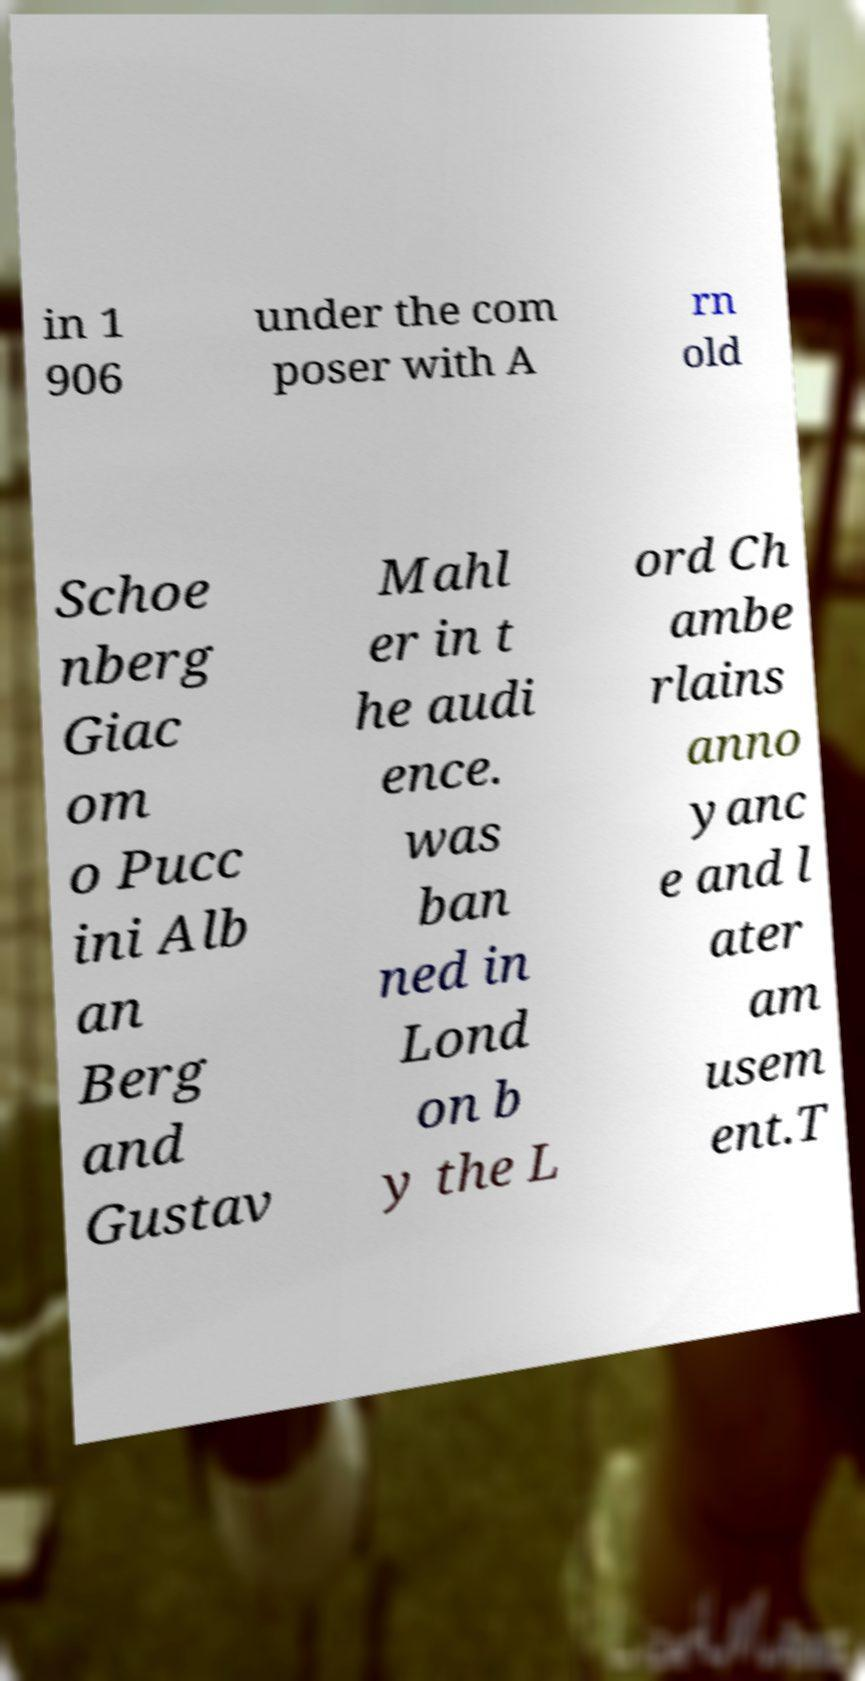Could you assist in decoding the text presented in this image and type it out clearly? in 1 906 under the com poser with A rn old Schoe nberg Giac om o Pucc ini Alb an Berg and Gustav Mahl er in t he audi ence. was ban ned in Lond on b y the L ord Ch ambe rlains anno yanc e and l ater am usem ent.T 